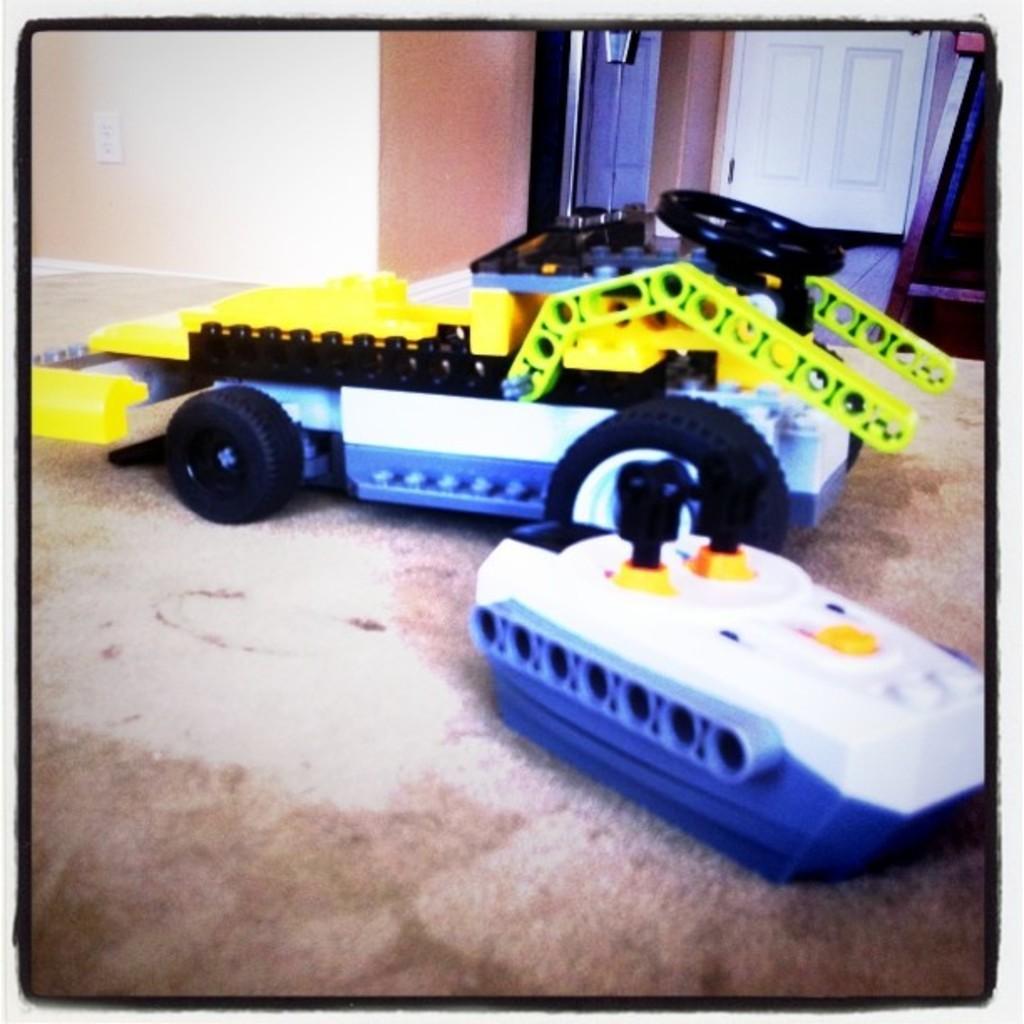How would you summarize this image in a sentence or two? This is the picture of a room. In the foreground there are toys on the mat. At the back there is a door and there is a table and there is an object and there is a switch board on the wall. At the bottom there is a mat on the floor. 